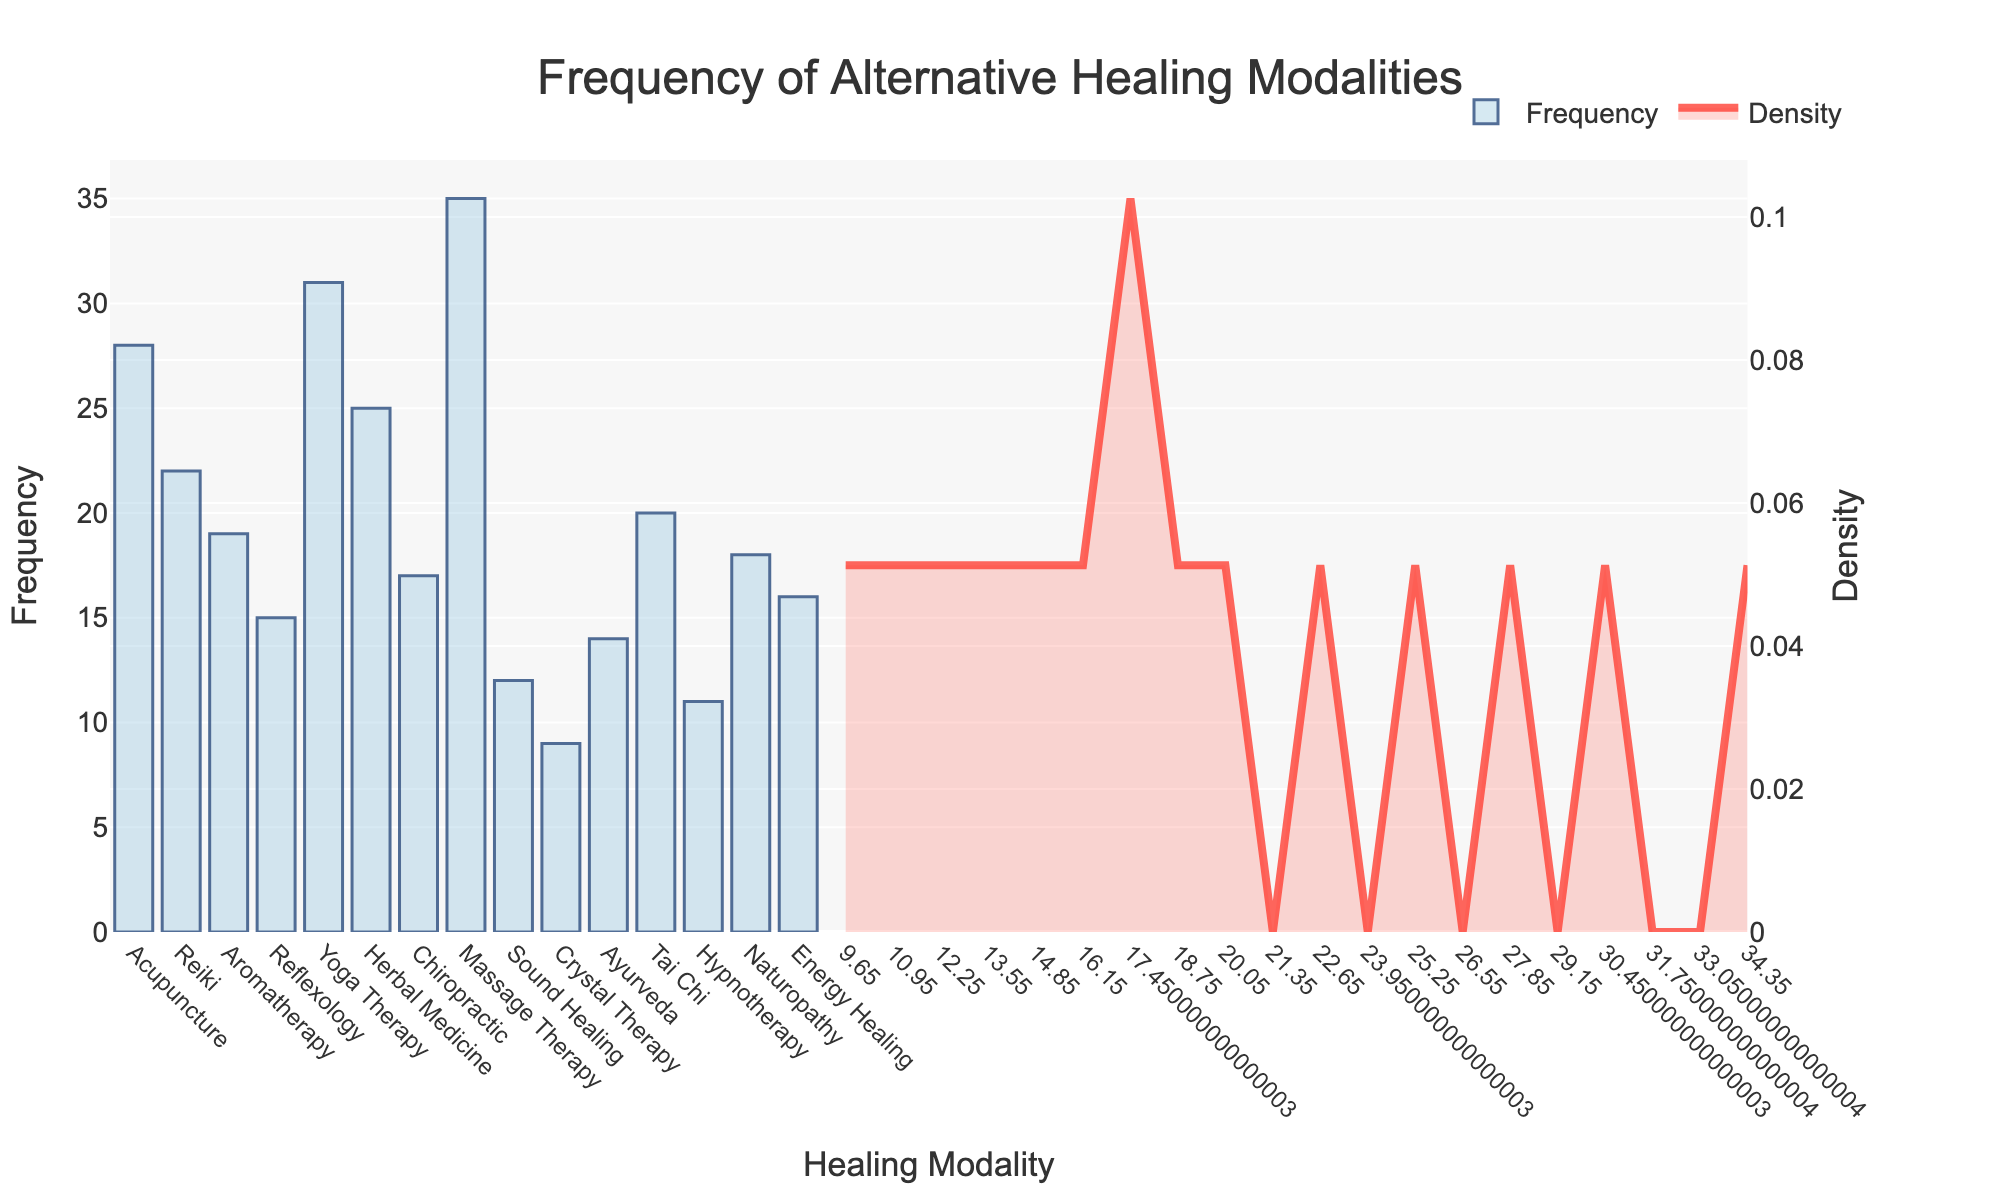Which modality has the highest frequency? By observing the height of the bars in the histogram, the highest bar represents the modality with the highest frequency, which is Massage Therapy.
Answer: Massage Therapy What is the title of the plot? The title is located at the top-center of the plot and reads "Frequency of Alternative Healing Modalities".
Answer: Frequency of Alternative Healing Modalities How many modalities have a frequency greater than 20? By counting the bars that exceed the frequency line of 20, we see Acupuncture, Reiki, Yoga Therapy, Herbal Medicine, and Massage Therapy.
Answer: 5 Which modality has the lowest frequency? The lowest bar on the histogram represents Crystal Therapy.
Answer: Crystal Therapy What is the average frequency of all modalities? Sum all frequency values and divide by the number of modalities: (28 + 22 + 19 + 15 + 31 + 25 + 17 + 35 + 12 + 9 + 14 + 20 + 11 + 18 + 16) / 15 = 292 / 15 ≈ 19.47.
Answer: ~19.47 Between Reiki and Tai Chi, which modality has a higher frequency and by how much? Reiki has a frequency of 22 and Tai Chi has a frequency of 20, so Reiki is higher by 2.
Answer: Reiki by 2 Which modality has a frequency closest to the average frequency? Calculating the differences between average frequency (~19.47) and each modality, Tai Chi has the frequency value (20) closest to the average.
Answer: Tai Chi What does the KDE curve represent in this plot? The KDE curve represents the density estimation of the frequency data, indicating how the frequencies are distributed.
Answer: Density of frequencies What is the modality with the third highest frequency? Sorting the frequencies, the third highest is held by Acupuncture.
Answer: Acupuncture 